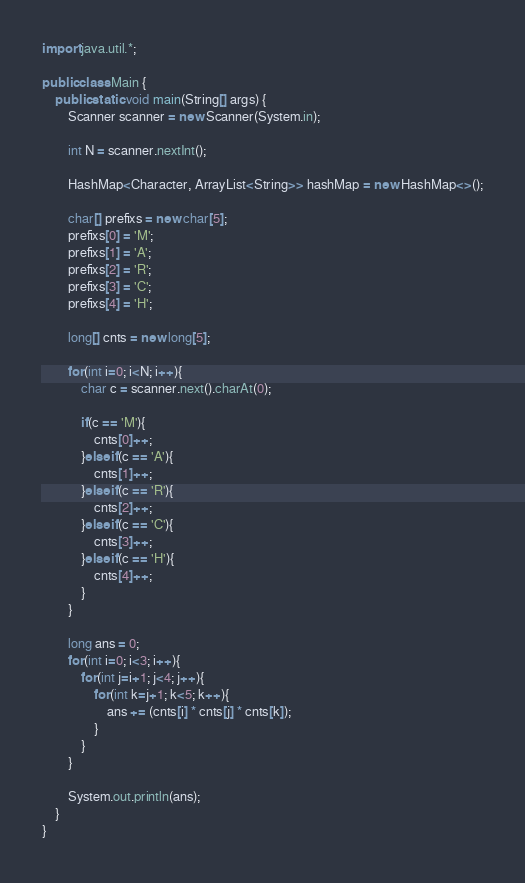<code> <loc_0><loc_0><loc_500><loc_500><_Java_>import java.util.*;

public class Main {
    public static void main(String[] args) {
        Scanner scanner = new Scanner(System.in);

        int N = scanner.nextInt();

        HashMap<Character, ArrayList<String>> hashMap = new HashMap<>();

        char[] prefixs = new char[5];
        prefixs[0] = 'M';
        prefixs[1] = 'A';
        prefixs[2] = 'R';
        prefixs[3] = 'C';
        prefixs[4] = 'H';

        long[] cnts = new long[5];

        for(int i=0; i<N; i++){
            char c = scanner.next().charAt(0);

            if(c == 'M'){
                cnts[0]++;
            }else if(c == 'A'){
                cnts[1]++;
            }else if(c == 'R'){
                cnts[2]++;
            }else if(c == 'C'){
                cnts[3]++;
            }else if(c == 'H'){
                cnts[4]++;
            }
        }

        long ans = 0;
        for(int i=0; i<3; i++){
            for(int j=i+1; j<4; j++){
                for(int k=j+1; k<5; k++){
                    ans += (cnts[i] * cnts[j] * cnts[k]);
                }
            }
        }

        System.out.println(ans);
    }
}
</code> 